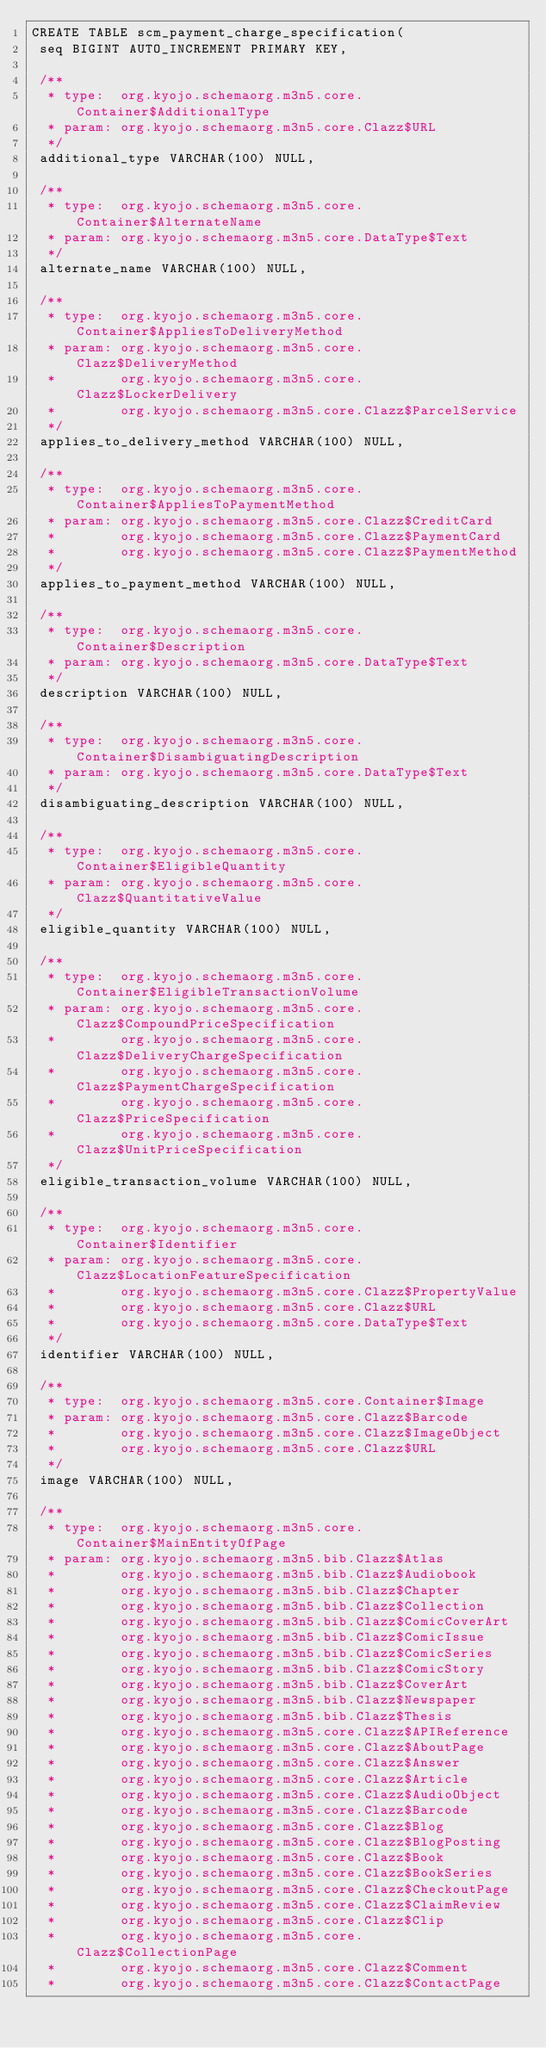<code> <loc_0><loc_0><loc_500><loc_500><_SQL_>CREATE TABLE scm_payment_charge_specification(
 seq BIGINT AUTO_INCREMENT PRIMARY KEY,

 /**
  * type:  org.kyojo.schemaorg.m3n5.core.Container$AdditionalType
  * param: org.kyojo.schemaorg.m3n5.core.Clazz$URL
  */
 additional_type VARCHAR(100) NULL,

 /**
  * type:  org.kyojo.schemaorg.m3n5.core.Container$AlternateName
  * param: org.kyojo.schemaorg.m3n5.core.DataType$Text
  */
 alternate_name VARCHAR(100) NULL,

 /**
  * type:  org.kyojo.schemaorg.m3n5.core.Container$AppliesToDeliveryMethod
  * param: org.kyojo.schemaorg.m3n5.core.Clazz$DeliveryMethod
  *        org.kyojo.schemaorg.m3n5.core.Clazz$LockerDelivery
  *        org.kyojo.schemaorg.m3n5.core.Clazz$ParcelService
  */
 applies_to_delivery_method VARCHAR(100) NULL,

 /**
  * type:  org.kyojo.schemaorg.m3n5.core.Container$AppliesToPaymentMethod
  * param: org.kyojo.schemaorg.m3n5.core.Clazz$CreditCard
  *        org.kyojo.schemaorg.m3n5.core.Clazz$PaymentCard
  *        org.kyojo.schemaorg.m3n5.core.Clazz$PaymentMethod
  */
 applies_to_payment_method VARCHAR(100) NULL,

 /**
  * type:  org.kyojo.schemaorg.m3n5.core.Container$Description
  * param: org.kyojo.schemaorg.m3n5.core.DataType$Text
  */
 description VARCHAR(100) NULL,

 /**
  * type:  org.kyojo.schemaorg.m3n5.core.Container$DisambiguatingDescription
  * param: org.kyojo.schemaorg.m3n5.core.DataType$Text
  */
 disambiguating_description VARCHAR(100) NULL,

 /**
  * type:  org.kyojo.schemaorg.m3n5.core.Container$EligibleQuantity
  * param: org.kyojo.schemaorg.m3n5.core.Clazz$QuantitativeValue
  */
 eligible_quantity VARCHAR(100) NULL,

 /**
  * type:  org.kyojo.schemaorg.m3n5.core.Container$EligibleTransactionVolume
  * param: org.kyojo.schemaorg.m3n5.core.Clazz$CompoundPriceSpecification
  *        org.kyojo.schemaorg.m3n5.core.Clazz$DeliveryChargeSpecification
  *        org.kyojo.schemaorg.m3n5.core.Clazz$PaymentChargeSpecification
  *        org.kyojo.schemaorg.m3n5.core.Clazz$PriceSpecification
  *        org.kyojo.schemaorg.m3n5.core.Clazz$UnitPriceSpecification
  */
 eligible_transaction_volume VARCHAR(100) NULL,

 /**
  * type:  org.kyojo.schemaorg.m3n5.core.Container$Identifier
  * param: org.kyojo.schemaorg.m3n5.core.Clazz$LocationFeatureSpecification
  *        org.kyojo.schemaorg.m3n5.core.Clazz$PropertyValue
  *        org.kyojo.schemaorg.m3n5.core.Clazz$URL
  *        org.kyojo.schemaorg.m3n5.core.DataType$Text
  */
 identifier VARCHAR(100) NULL,

 /**
  * type:  org.kyojo.schemaorg.m3n5.core.Container$Image
  * param: org.kyojo.schemaorg.m3n5.core.Clazz$Barcode
  *        org.kyojo.schemaorg.m3n5.core.Clazz$ImageObject
  *        org.kyojo.schemaorg.m3n5.core.Clazz$URL
  */
 image VARCHAR(100) NULL,

 /**
  * type:  org.kyojo.schemaorg.m3n5.core.Container$MainEntityOfPage
  * param: org.kyojo.schemaorg.m3n5.bib.Clazz$Atlas
  *        org.kyojo.schemaorg.m3n5.bib.Clazz$Audiobook
  *        org.kyojo.schemaorg.m3n5.bib.Clazz$Chapter
  *        org.kyojo.schemaorg.m3n5.bib.Clazz$Collection
  *        org.kyojo.schemaorg.m3n5.bib.Clazz$ComicCoverArt
  *        org.kyojo.schemaorg.m3n5.bib.Clazz$ComicIssue
  *        org.kyojo.schemaorg.m3n5.bib.Clazz$ComicSeries
  *        org.kyojo.schemaorg.m3n5.bib.Clazz$ComicStory
  *        org.kyojo.schemaorg.m3n5.bib.Clazz$CoverArt
  *        org.kyojo.schemaorg.m3n5.bib.Clazz$Newspaper
  *        org.kyojo.schemaorg.m3n5.bib.Clazz$Thesis
  *        org.kyojo.schemaorg.m3n5.core.Clazz$APIReference
  *        org.kyojo.schemaorg.m3n5.core.Clazz$AboutPage
  *        org.kyojo.schemaorg.m3n5.core.Clazz$Answer
  *        org.kyojo.schemaorg.m3n5.core.Clazz$Article
  *        org.kyojo.schemaorg.m3n5.core.Clazz$AudioObject
  *        org.kyojo.schemaorg.m3n5.core.Clazz$Barcode
  *        org.kyojo.schemaorg.m3n5.core.Clazz$Blog
  *        org.kyojo.schemaorg.m3n5.core.Clazz$BlogPosting
  *        org.kyojo.schemaorg.m3n5.core.Clazz$Book
  *        org.kyojo.schemaorg.m3n5.core.Clazz$BookSeries
  *        org.kyojo.schemaorg.m3n5.core.Clazz$CheckoutPage
  *        org.kyojo.schemaorg.m3n5.core.Clazz$ClaimReview
  *        org.kyojo.schemaorg.m3n5.core.Clazz$Clip
  *        org.kyojo.schemaorg.m3n5.core.Clazz$CollectionPage
  *        org.kyojo.schemaorg.m3n5.core.Clazz$Comment
  *        org.kyojo.schemaorg.m3n5.core.Clazz$ContactPage</code> 